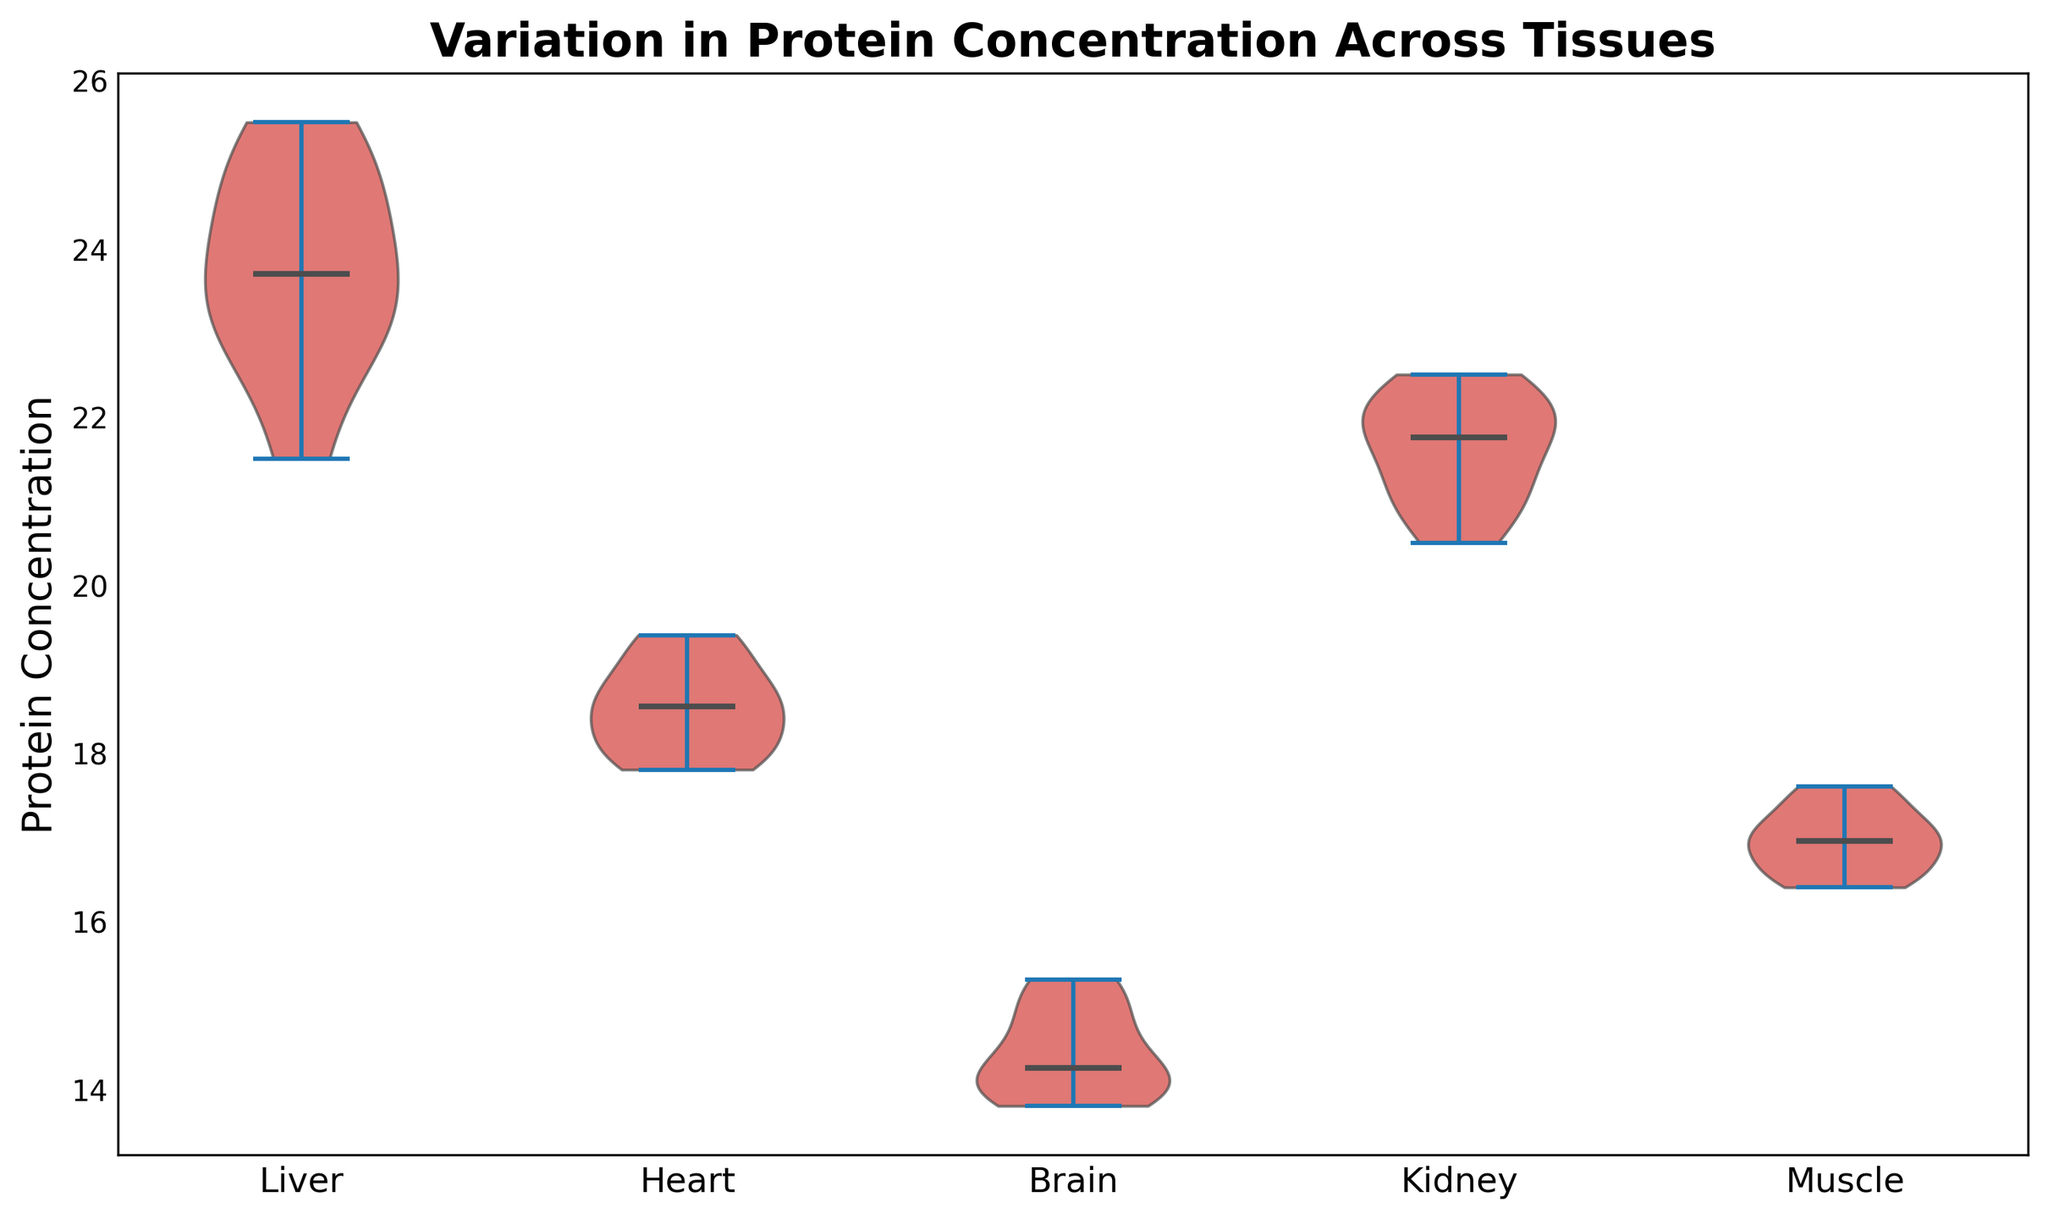What is the median protein concentration for Liver tissue? To find the median protein concentration for Liver tissue, locate the horizontal line within the portion of the violin plot corresponding to the Liver. The median is where this line intersects the vertical axis labeled 'Protein Concentration'.
Answer: 23.9 Which tissue has the highest median protein concentration? Look at the horizontal lines indicating the medians in each violin plot segment. Compare their positions on the vertical axis to see which is the highest.
Answer: Liver How does the spread (range) of protein concentration in the Liver compare to that in the Brain? The spread or range can be visualized by noting the full vertical extent of the violin plot sections for Liver and Brain tissues. Compare the vertical range from top to bottom for both tissues.
Answer: Liver has a wider range than Brain What visual attributes indicate the median protein concentration in the plot? The median protein concentration is indicated by the horizontal line inside each violin plot section, corresponding to the middle value on the vertical axis labeled 'Protein Concentration'.
Answer: Horizontal line inside each violin plot section Is the median protein concentration in Heart tissue higher or lower than in Muscle tissue? To determine this, examine the intersection of the median horizontal lines in Heart and Muscle violin plot sections with the vertical axis. Compare their positions.
Answer: Higher Rank the tissues from lowest to highest in terms of their median protein concentration. Examine the horizontal lines representing the medians in each violin plot section and rank from lowest to highest: Brain, Muscle, Heart, Kidney, Liver.
Answer: Brain, Muscle, Heart, Kidney, Liver What's the average spread of protein concentration across all tissues? To get the average spread, sum up the range (max - min values visually estimated) of protein concentrations for each tissue and divide by the number of tissues. Suppose visual estimation reveals spreads roughly as Liver (4), Kidney (2), Heart (2), Brain (2), Muscle (1). Sum = 4+2+2+2+1 = 11. Average spread = 11/5.
Answer: 2.2 Which tissue displays the smallest variability in protein concentration? Assess the narrowness of the violin plot sections vertically, noting the intersection of lower and upper distribution limits for each tissue to find the one with the smallest spread.
Answer: Muscle 